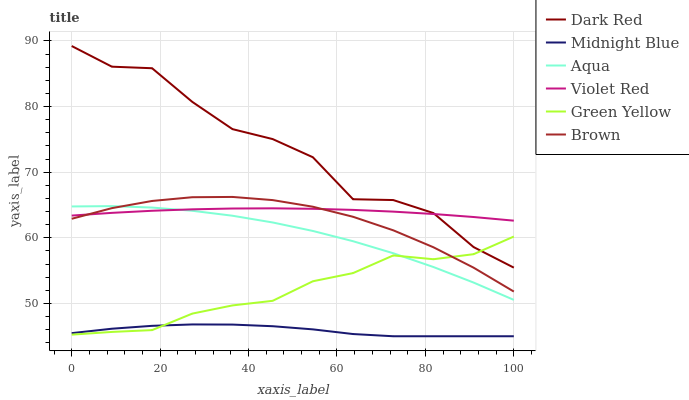Does Midnight Blue have the minimum area under the curve?
Answer yes or no. Yes. Does Dark Red have the maximum area under the curve?
Answer yes or no. Yes. Does Violet Red have the minimum area under the curve?
Answer yes or no. No. Does Violet Red have the maximum area under the curve?
Answer yes or no. No. Is Violet Red the smoothest?
Answer yes or no. Yes. Is Dark Red the roughest?
Answer yes or no. Yes. Is Midnight Blue the smoothest?
Answer yes or no. No. Is Midnight Blue the roughest?
Answer yes or no. No. Does Midnight Blue have the lowest value?
Answer yes or no. Yes. Does Violet Red have the lowest value?
Answer yes or no. No. Does Dark Red have the highest value?
Answer yes or no. Yes. Does Violet Red have the highest value?
Answer yes or no. No. Is Green Yellow less than Violet Red?
Answer yes or no. Yes. Is Violet Red greater than Green Yellow?
Answer yes or no. Yes. Does Midnight Blue intersect Green Yellow?
Answer yes or no. Yes. Is Midnight Blue less than Green Yellow?
Answer yes or no. No. Is Midnight Blue greater than Green Yellow?
Answer yes or no. No. Does Green Yellow intersect Violet Red?
Answer yes or no. No. 